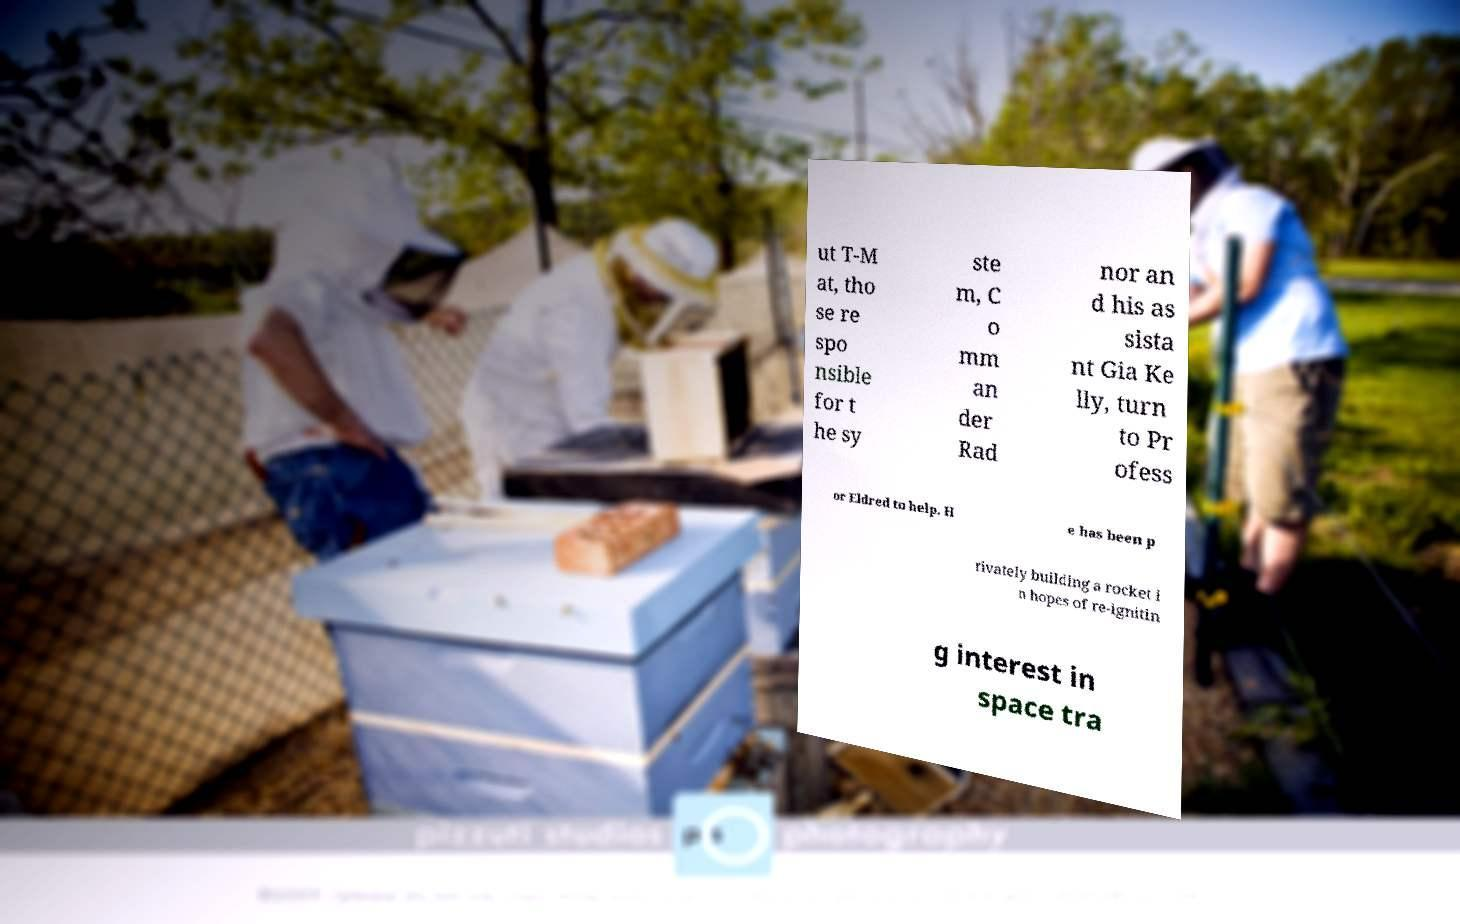Could you assist in decoding the text presented in this image and type it out clearly? ut T-M at, tho se re spo nsible for t he sy ste m, C o mm an der Rad nor an d his as sista nt Gia Ke lly, turn to Pr ofess or Eldred to help. H e has been p rivately building a rocket i n hopes of re-ignitin g interest in space tra 